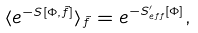Convert formula to latex. <formula><loc_0><loc_0><loc_500><loc_500>\langle e ^ { - S [ \Phi , \tilde { f } ] } \rangle _ { \tilde { f } } = e ^ { - S ^ { \prime } _ { e f f } [ \Phi ] } ,</formula> 